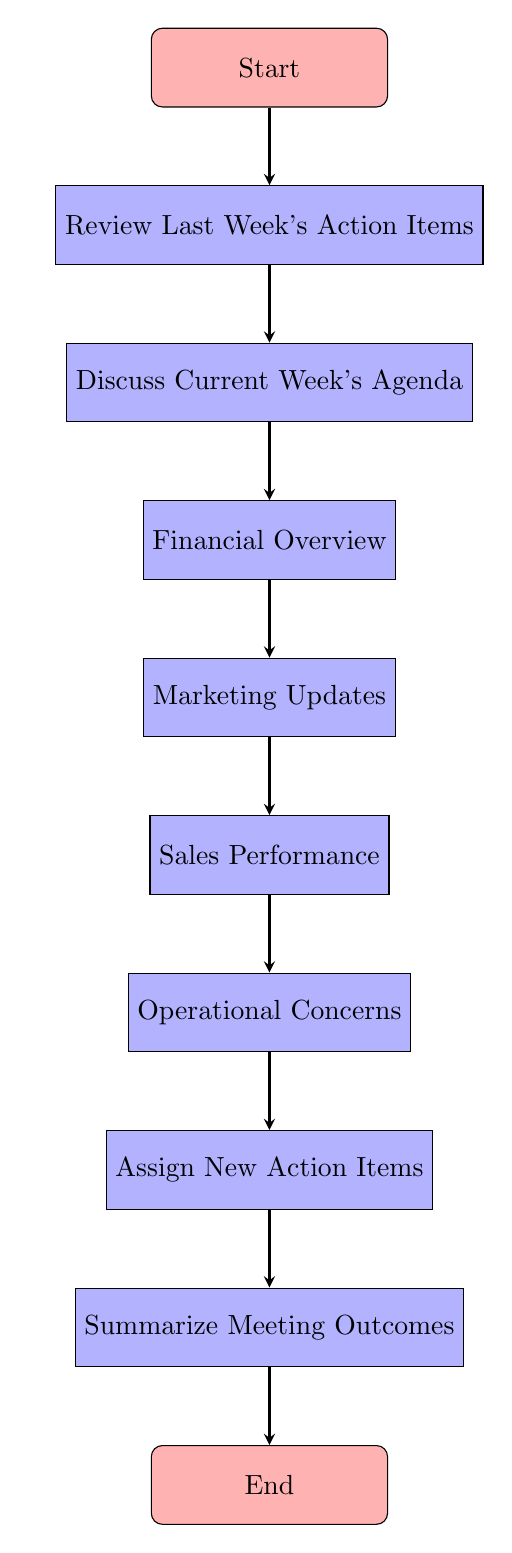What is the first node of the flow chart? The first node is labeled "Start", which initiates the sequence of actions outlined in the flow chart.
Answer: Start How many total nodes are present in the flow chart? By counting each node listed in the data provided, there are ten nodes in total.
Answer: 10 What is the final action taken in the flow chart? The last node before concluding the diagram is labeled "End", indicating that all actions and discussions have been completed.
Answer: End Which node follows "Review Last Week's Action Items"? The arrow indicates that the next step after "Review Last Week's Action Items" is to "Discuss Current Week's Agenda".
Answer: Discuss Current Week's Agenda What type of updates are discussed after "Financial Overview"? The flow chart shows that "Marketing Updates" are the next discussion topic following the financial overview.
Answer: Marketing Updates What is the third step in the sequence of actions? Following the flow from the first node, the third step is characterized by "Financial Overview". This shows the specific point in the agenda.
Answer: Financial Overview How many action items are assigned before summarizing meeting outcomes? The flow indicates that only one action is assigned after discussing "Operational Concerns" before moving to summarize meeting outcomes.
Answer: 1 Which node connects "Sales Performance" to the next step? The flow chart shows that the arrow connects "Sales Performance" to "Operational Concerns", illustrating the transition in the meeting agenda.
Answer: Operational Concerns Which two nodes connect the section discussing current week's agenda and the assignments of new action items? The nodes "Discuss Current Week's Agenda" and "Assign New Action Items" are linked by the flow line, highlighting their sequential relationship in the meeting process.
Answer: Discuss Current Week's Agenda, Assign New Action Items 